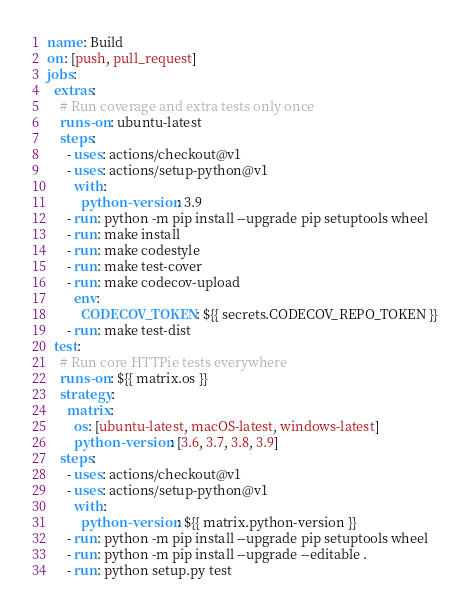Convert code to text. <code><loc_0><loc_0><loc_500><loc_500><_YAML_>name: Build
on: [push, pull_request]
jobs:
  extras:
    # Run coverage and extra tests only once
    runs-on: ubuntu-latest
    steps:
      - uses: actions/checkout@v1
      - uses: actions/setup-python@v1
        with:
          python-version: 3.9
      - run: python -m pip install --upgrade pip setuptools wheel
      - run: make install
      - run: make codestyle
      - run: make test-cover
      - run: make codecov-upload
        env:
          CODECOV_TOKEN: ${{ secrets.CODECOV_REPO_TOKEN }}
      - run: make test-dist
  test:
    # Run core HTTPie tests everywhere
    runs-on: ${{ matrix.os }}
    strategy:
      matrix:
        os: [ubuntu-latest, macOS-latest, windows-latest]
        python-version: [3.6, 3.7, 3.8, 3.9]
    steps:
      - uses: actions/checkout@v1
      - uses: actions/setup-python@v1
        with:
          python-version: ${{ matrix.python-version }}
      - run: python -m pip install --upgrade pip setuptools wheel
      - run: python -m pip install --upgrade --editable .
      - run: python setup.py test
</code> 